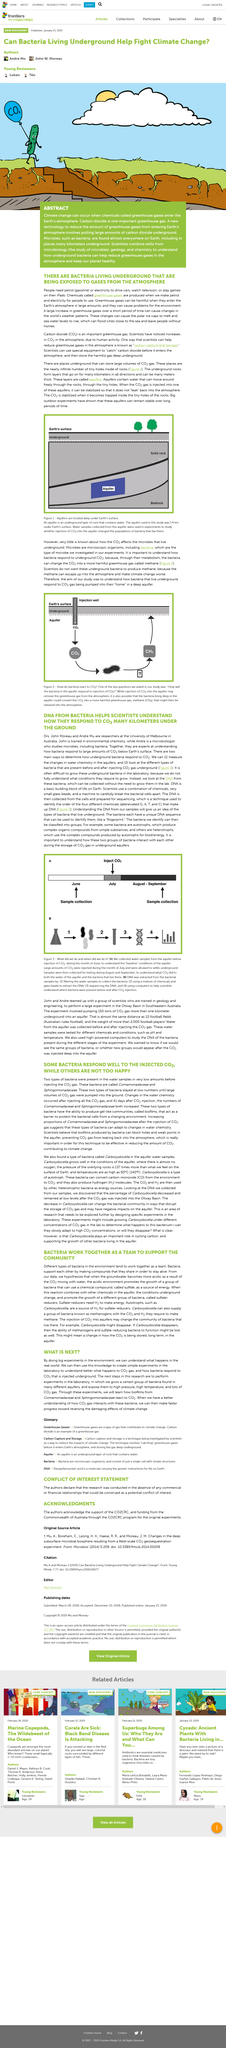List a handful of essential elements in this visual. Heterotrophs are organisms that rely on complex organic compounds produced by other organisms, commonly known as autotrophs, for food and energy. These compounds are produced through photosynthesis, a process in which autotrophs use sunlight to convert carbon dioxide and water into organic matter. Heterotrophs consume these organic compounds and use them as energy and nutrients for their own growth and survival. Carbon capture and storage, commonly referred to as, is a method by which scientists aim to decrease greenhouse gases in the atmosphere. Scientists are against the existence of underground bacteria that produce methane because the released methane can escape into the atmosphere and contribute to the worsening of climate change. Autotrophs are organisms that produce complex organic compounds from simple substances through a process of photosynthesis or chemosynthesis. The abbreviation "CO2" in this article refers to the chemical compound carbon dioxide. 